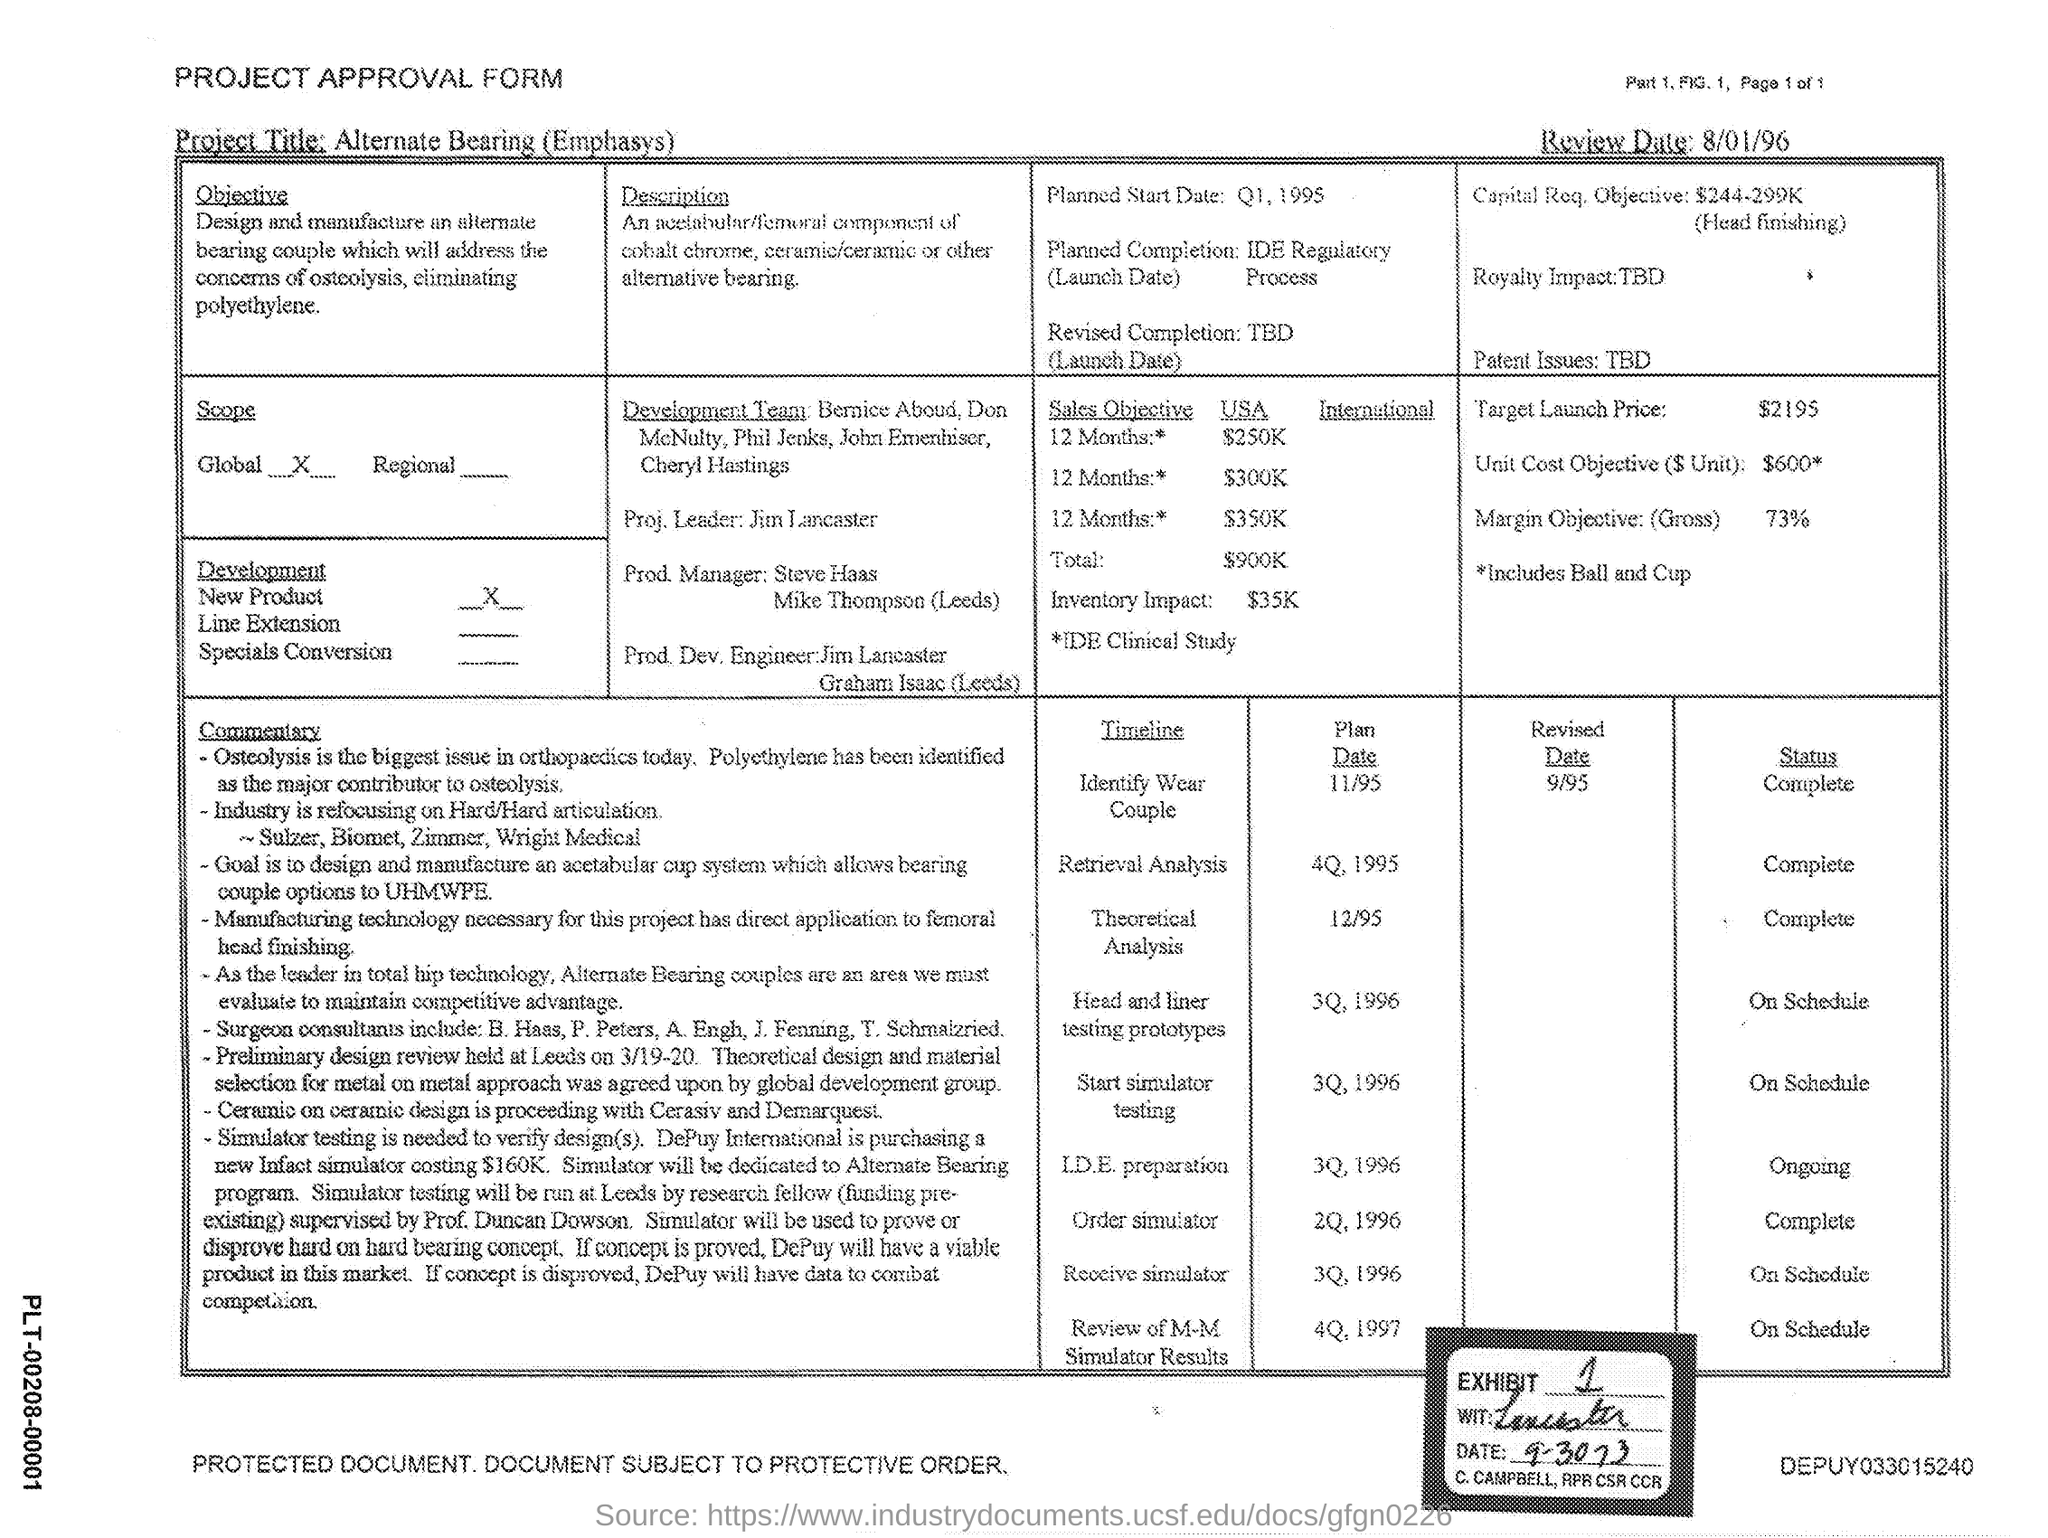Identify some key points in this picture. The review date mentioned in the form is August 1, 1996. This is a declaration that the form being referred to is a "PROJECT APPROVAL FORM. The leader of the development team is Jim Lancaster. The target launch price mentioned in the form is 2195. The scope of the project is to address the issue of gun violence within the United States by collecting and analyzing data on various factors that contribute to gun violence, such as the relationship between gun ownership and crime rates, the impact of gun control laws, and the role of mental illness. This project aims to provide a comprehensive understanding of the problem of gun violence, and to identify potential solutions that could be implemented to reduce the number of gun-related crimes. 